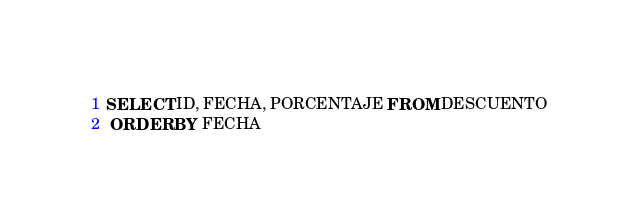<code> <loc_0><loc_0><loc_500><loc_500><_SQL_>SELECT ID, FECHA, PORCENTAJE FROM DESCUENTO
 ORDER BY FECHA  </code> 